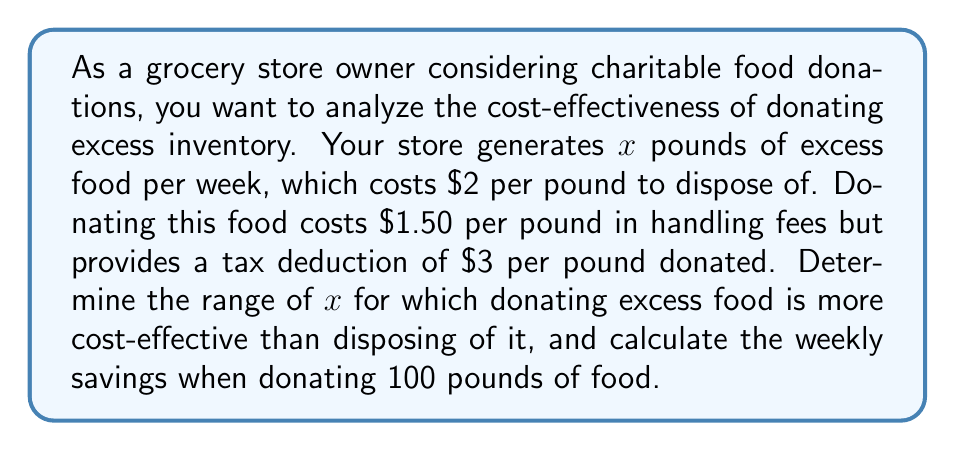Teach me how to tackle this problem. Let's approach this step-by-step:

1) First, let's define our variables:
   $x$ = pounds of excess food per week
   $C_d$ = cost of disposing food
   $C_n$ = net cost of donating food (after tax deduction)

2) Cost of disposing food:
   $C_d = 2x$

3) Cost of donating food:
   Handling fee: $1.50x$
   Tax deduction: $3x$
   Net cost: $C_n = 1.50x - 3x = -1.50x$

4) For donating to be more cost-effective:
   $C_n < C_d$
   $-1.50x < 2x$
   $3.50x > 0$
   $x > 0$

5) This means donating is always more cost-effective when there's excess food to donate.

6) To calculate weekly savings when donating 100 pounds:
   Savings = Cost of disposing - Net cost of donating
   $S = C_d - C_n = 2(100) - (-1.50)(100) = 200 + 150 = 350$

Therefore, the weekly savings when donating 100 pounds of food is $350.
Answer: $x > 0$; $\$350$ 